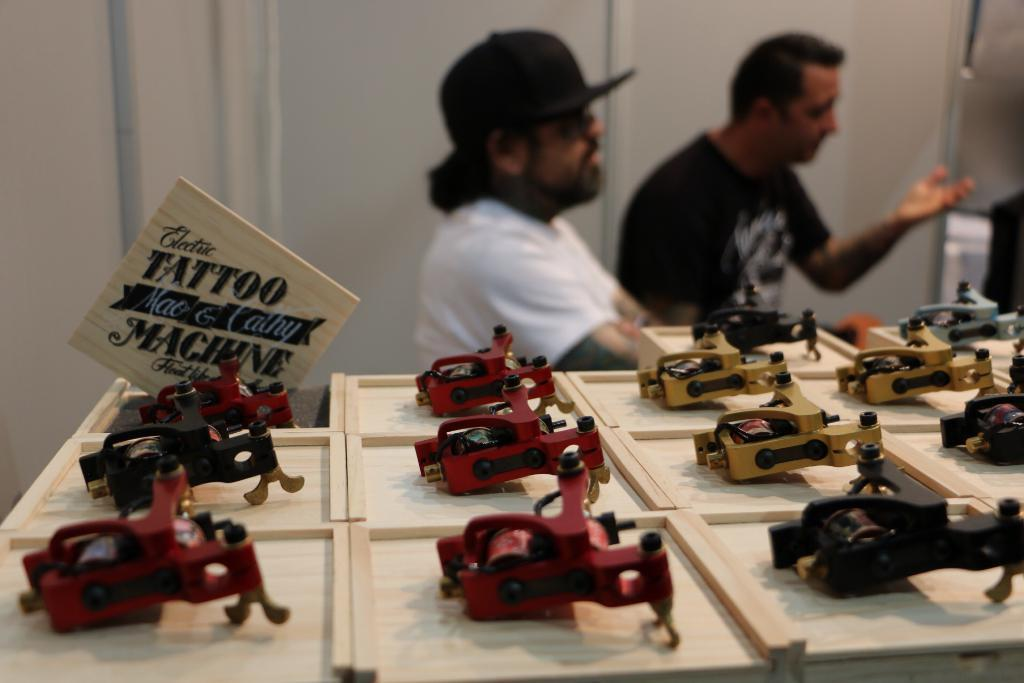What is the surface on which the objects are placed in the image? The objects are placed on a wooden surface in the image. Can you describe the background of the image? The background of the image is blurred, making it difficult to see details. How many people are present in the image? There are two people in the image. What is one person wearing that is distinctive? One person is wearing a cap. How many pizzas are being agreed upon by the two people in the image? There are no pizzas present in the image, nor is there any indication of an agreement between the two people. 